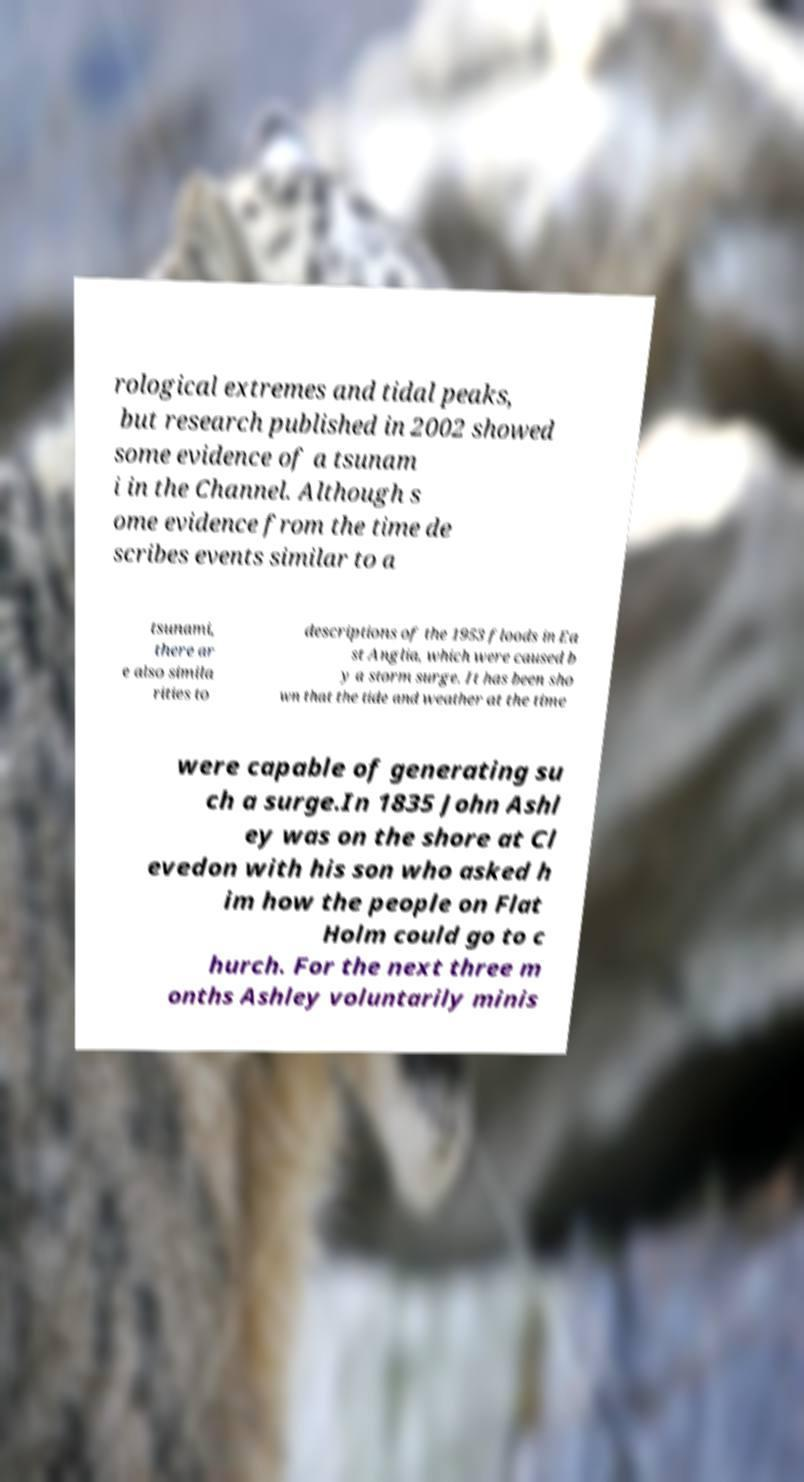Could you extract and type out the text from this image? rological extremes and tidal peaks, but research published in 2002 showed some evidence of a tsunam i in the Channel. Although s ome evidence from the time de scribes events similar to a tsunami, there ar e also simila rities to descriptions of the 1953 floods in Ea st Anglia, which were caused b y a storm surge. It has been sho wn that the tide and weather at the time were capable of generating su ch a surge.In 1835 John Ashl ey was on the shore at Cl evedon with his son who asked h im how the people on Flat Holm could go to c hurch. For the next three m onths Ashley voluntarily minis 